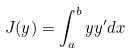<formula> <loc_0><loc_0><loc_500><loc_500>J ( y ) = \int _ { a } ^ { b } y y ^ { \prime } d x</formula> 